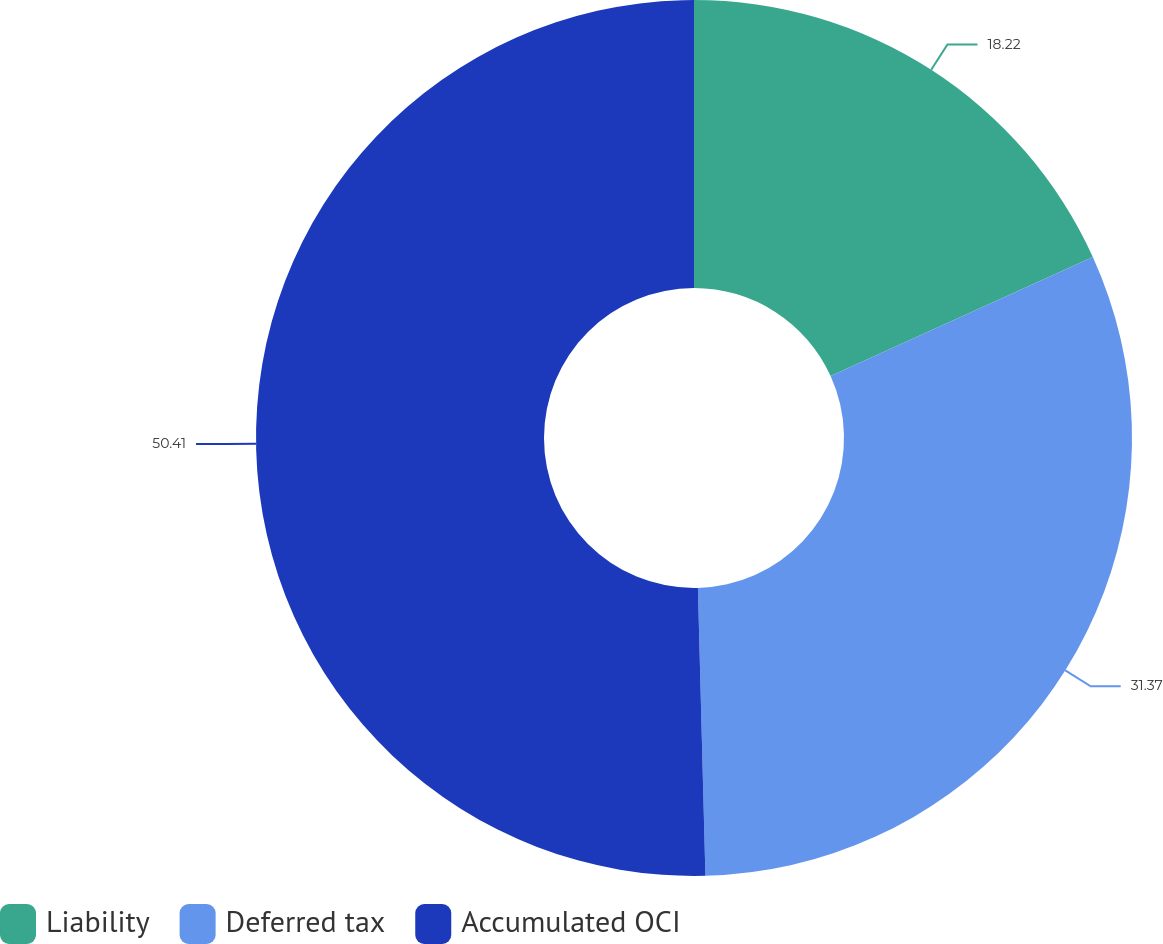Convert chart to OTSL. <chart><loc_0><loc_0><loc_500><loc_500><pie_chart><fcel>Liability<fcel>Deferred tax<fcel>Accumulated OCI<nl><fcel>18.22%<fcel>31.37%<fcel>50.42%<nl></chart> 